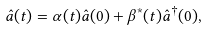<formula> <loc_0><loc_0><loc_500><loc_500>\hat { a } ( t ) = \alpha ( t ) \hat { a } ( 0 ) + \beta ^ { * } ( t ) \hat { a } ^ { \dagger } ( 0 ) ,</formula> 